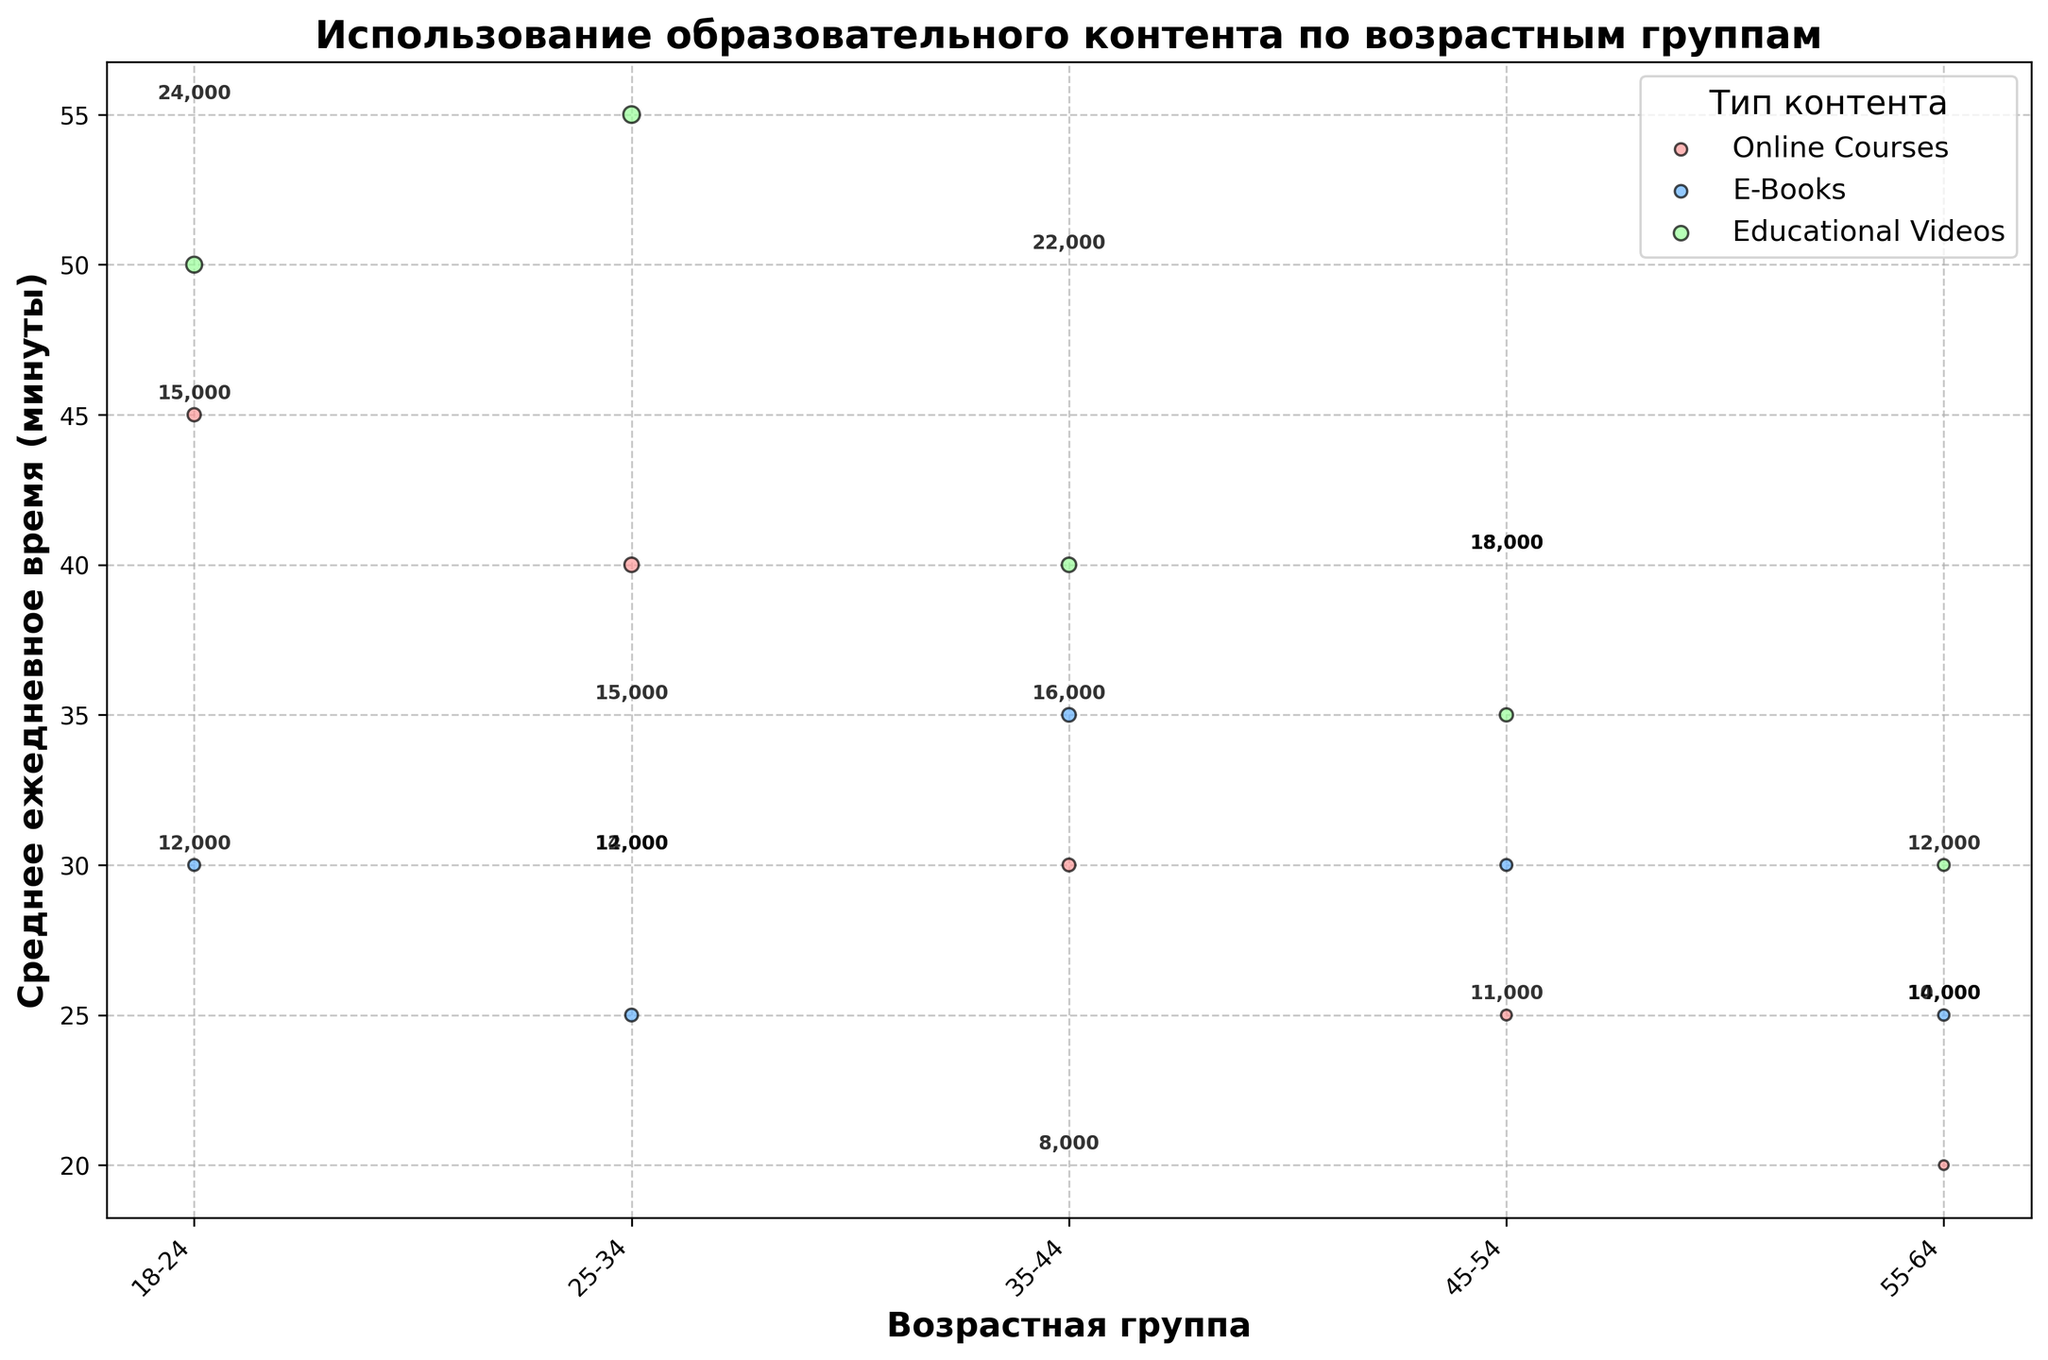What is the title of the figure? The title of the figure is displayed at the top. It should describe what the chart is about.
Answer: Использование образовательного контента по возрастным группам How many content types are represented in the figure? The legend shows different content types indicated by different colors. Count how many unique content types are listed in the legend.
Answer: 3 Which age group spends the most average daily time on educational videos? Look for the largest bubble in the color representing educational videos and check its corresponding age group.
Answer: 25-34 What is the average daily time spent on e-books for the 35-44 age group? Find the bubble for e-books (distinguished by a unique color) within the 35-44 age group and read the y-axis value.
Answer: 35 minutes Among all age groups, which has the least platform users for online courses? Locate the smallest bubble representing online courses across all age groups and identify its age group.
Answer: 55-64 Compare the average daily time spent on online courses between the 18-24 and 55-64 age groups. Find the bubbles for online courses within these age groups, read their y-axis values, and compare them.
Answer: 45 minutes (18-24), 20 minutes (55-64) Which age group shows the highest engagement in terms of average daily time on e-books? Look at all bubbles representing e-books and identify the one with the highest position on the y-axis.
Answer: 35-44 What is the total number of platform users for educational videos across all age groups? Sum the platform users for educational videos across all listed age groups. Detailed steps: 22000 (18-24) + 24000 (25-34) + 18000 (35-44) + 15000 (45-54) + 12000 (55-64).
Answer: 91000 For the 25-34 age group, compare the average daily time spent on educational videos versus e-books. Find the bubbles for educational videos and e-books within the 25-34 age group, read their y-axis values, and compare them.
Answer: 55 minutes (educational videos), 25 minutes (e-books) Discuss the trend in the average daily time spent on online courses as age increases from 18-24 to 55-64. Look at the y-axis values for online courses across all age groups and note the changes as age increases.
Answer: The average daily time decreases from 45 minutes (18-24) to 20 minutes (55-64) 